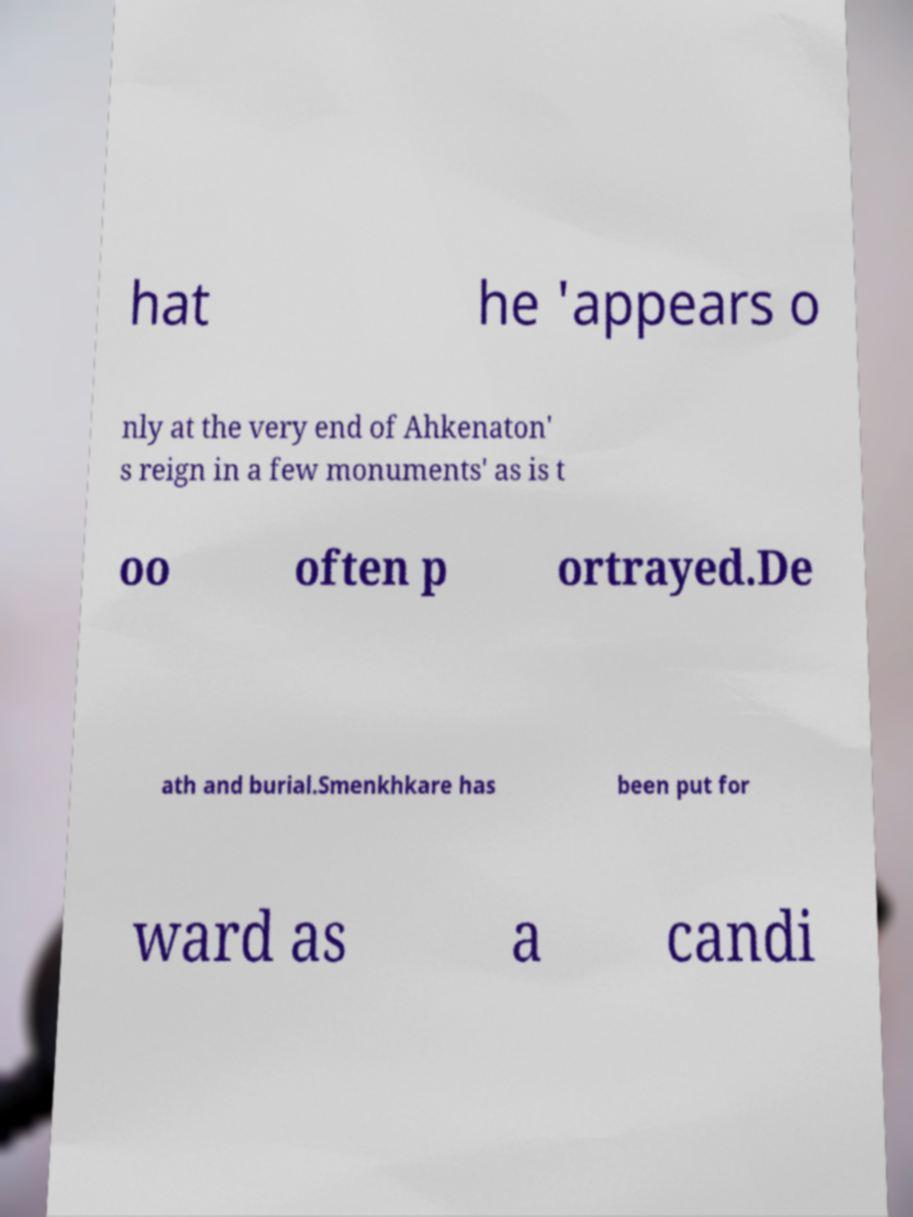Please read and relay the text visible in this image. What does it say? hat he 'appears o nly at the very end of Ahkenaton' s reign in a few monuments' as is t oo often p ortrayed.De ath and burial.Smenkhkare has been put for ward as a candi 